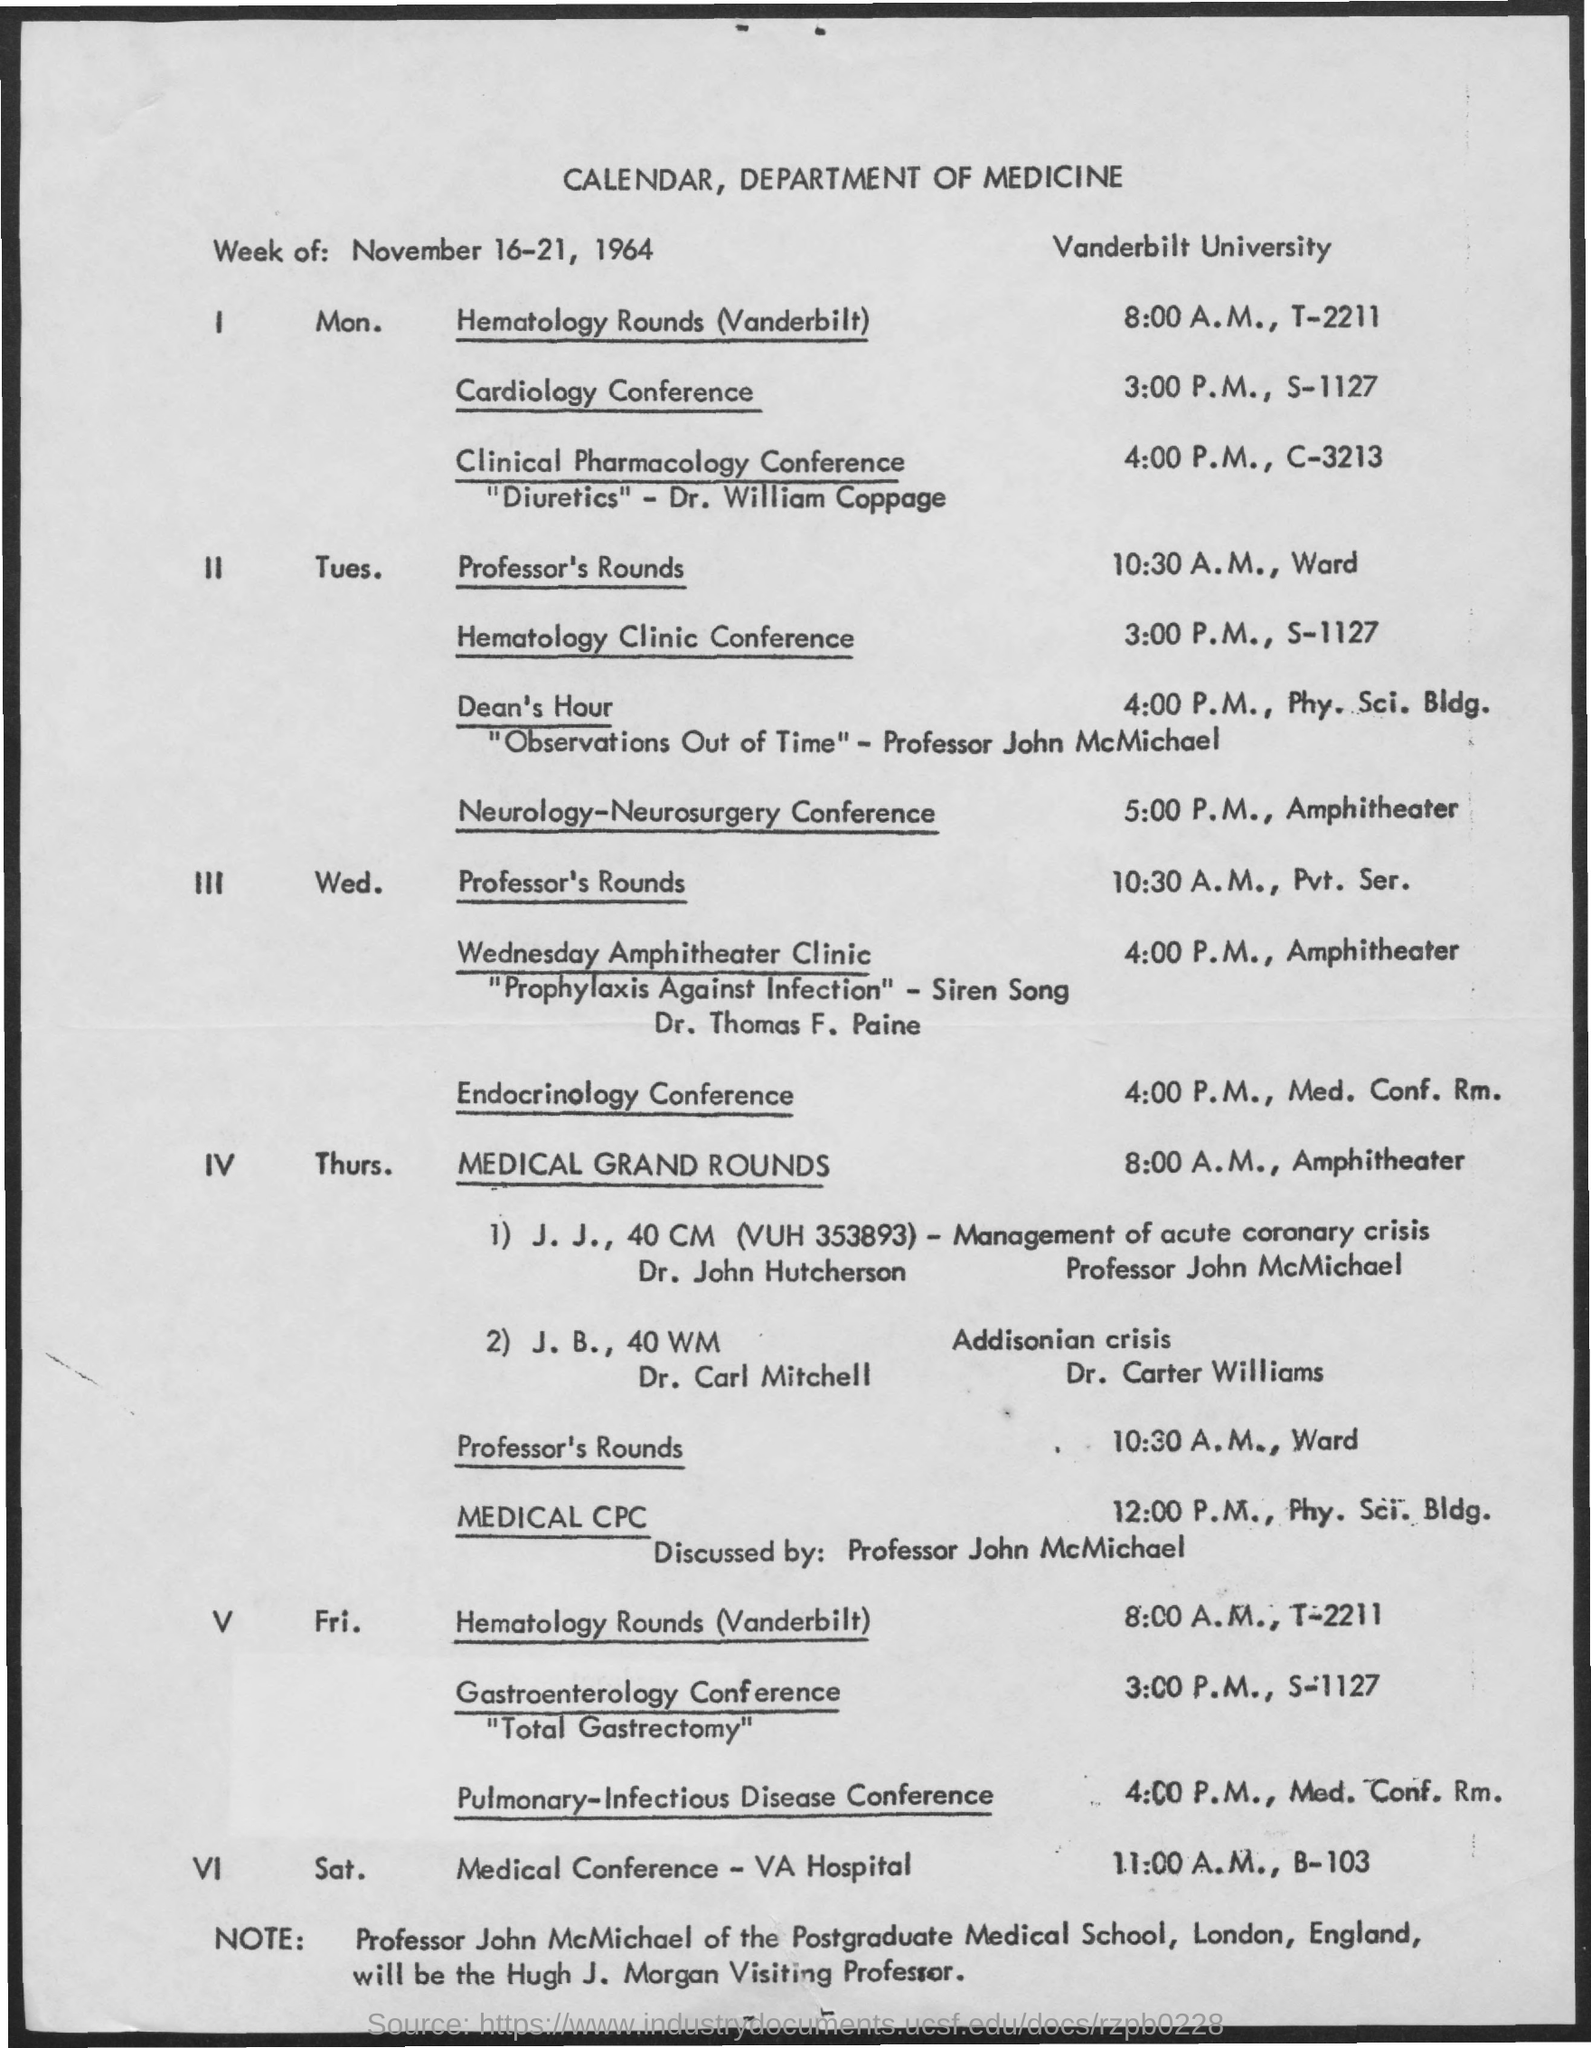What is the heading of document on top?
Provide a succinct answer. Calendar, Department Of Medicine. Medical CPC is discussed by?
Make the answer very short. Professor John McMichael. 